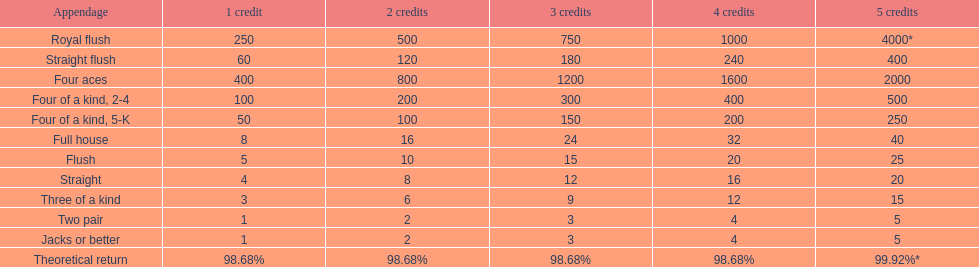Is four 5s worth more or less than four 2s? Less. 